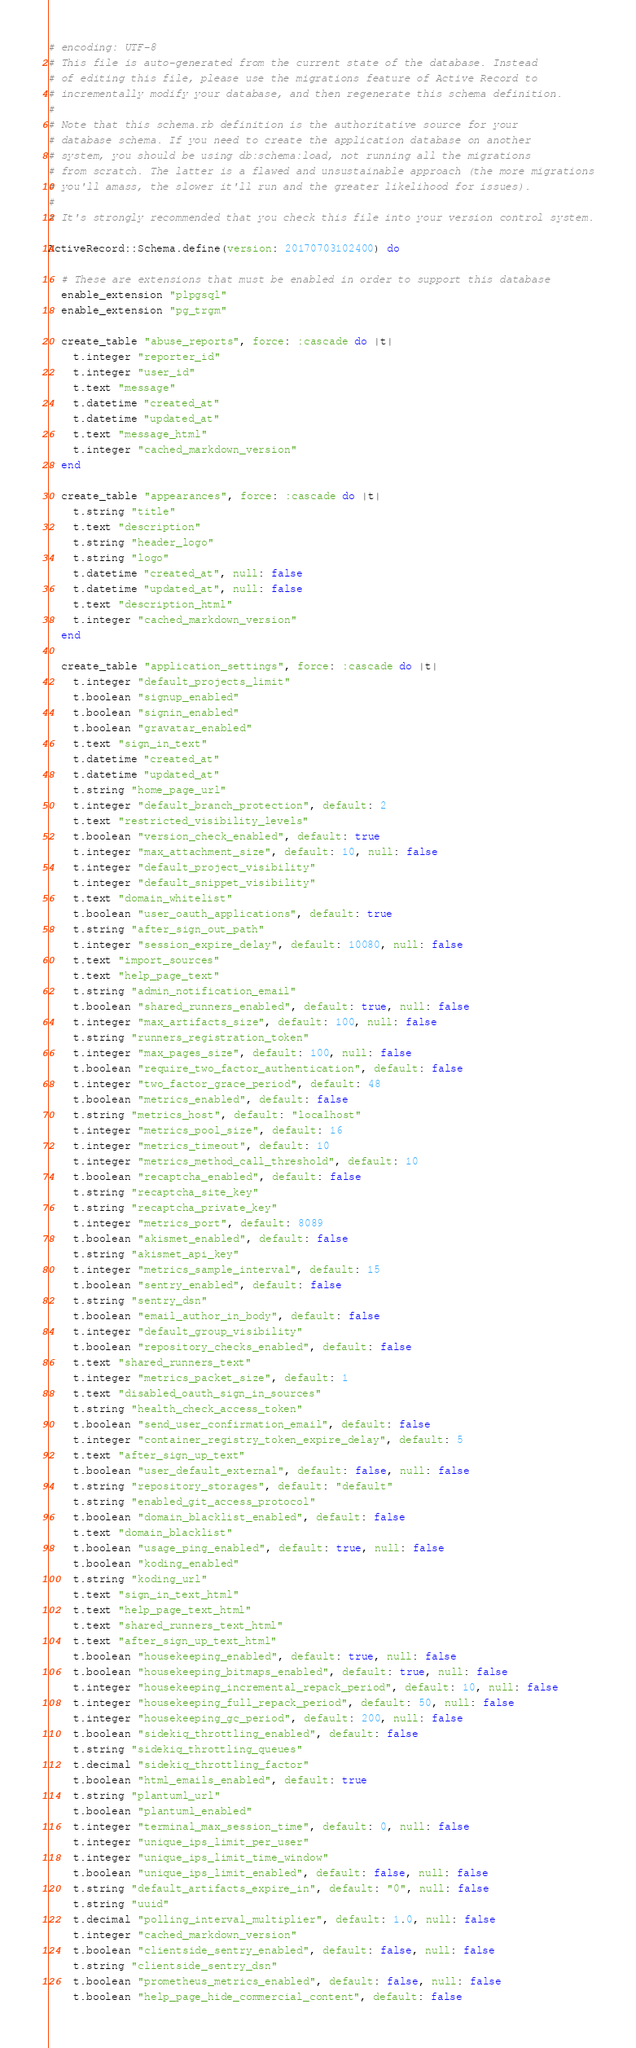<code> <loc_0><loc_0><loc_500><loc_500><_Ruby_># encoding: UTF-8
# This file is auto-generated from the current state of the database. Instead
# of editing this file, please use the migrations feature of Active Record to
# incrementally modify your database, and then regenerate this schema definition.
#
# Note that this schema.rb definition is the authoritative source for your
# database schema. If you need to create the application database on another
# system, you should be using db:schema:load, not running all the migrations
# from scratch. The latter is a flawed and unsustainable approach (the more migrations
# you'll amass, the slower it'll run and the greater likelihood for issues).
#
# It's strongly recommended that you check this file into your version control system.

ActiveRecord::Schema.define(version: 20170703102400) do

  # These are extensions that must be enabled in order to support this database
  enable_extension "plpgsql"
  enable_extension "pg_trgm"

  create_table "abuse_reports", force: :cascade do |t|
    t.integer "reporter_id"
    t.integer "user_id"
    t.text "message"
    t.datetime "created_at"
    t.datetime "updated_at"
    t.text "message_html"
    t.integer "cached_markdown_version"
  end

  create_table "appearances", force: :cascade do |t|
    t.string "title"
    t.text "description"
    t.string "header_logo"
    t.string "logo"
    t.datetime "created_at", null: false
    t.datetime "updated_at", null: false
    t.text "description_html"
    t.integer "cached_markdown_version"
  end

  create_table "application_settings", force: :cascade do |t|
    t.integer "default_projects_limit"
    t.boolean "signup_enabled"
    t.boolean "signin_enabled"
    t.boolean "gravatar_enabled"
    t.text "sign_in_text"
    t.datetime "created_at"
    t.datetime "updated_at"
    t.string "home_page_url"
    t.integer "default_branch_protection", default: 2
    t.text "restricted_visibility_levels"
    t.boolean "version_check_enabled", default: true
    t.integer "max_attachment_size", default: 10, null: false
    t.integer "default_project_visibility"
    t.integer "default_snippet_visibility"
    t.text "domain_whitelist"
    t.boolean "user_oauth_applications", default: true
    t.string "after_sign_out_path"
    t.integer "session_expire_delay", default: 10080, null: false
    t.text "import_sources"
    t.text "help_page_text"
    t.string "admin_notification_email"
    t.boolean "shared_runners_enabled", default: true, null: false
    t.integer "max_artifacts_size", default: 100, null: false
    t.string "runners_registration_token"
    t.integer "max_pages_size", default: 100, null: false
    t.boolean "require_two_factor_authentication", default: false
    t.integer "two_factor_grace_period", default: 48
    t.boolean "metrics_enabled", default: false
    t.string "metrics_host", default: "localhost"
    t.integer "metrics_pool_size", default: 16
    t.integer "metrics_timeout", default: 10
    t.integer "metrics_method_call_threshold", default: 10
    t.boolean "recaptcha_enabled", default: false
    t.string "recaptcha_site_key"
    t.string "recaptcha_private_key"
    t.integer "metrics_port", default: 8089
    t.boolean "akismet_enabled", default: false
    t.string "akismet_api_key"
    t.integer "metrics_sample_interval", default: 15
    t.boolean "sentry_enabled", default: false
    t.string "sentry_dsn"
    t.boolean "email_author_in_body", default: false
    t.integer "default_group_visibility"
    t.boolean "repository_checks_enabled", default: false
    t.text "shared_runners_text"
    t.integer "metrics_packet_size", default: 1
    t.text "disabled_oauth_sign_in_sources"
    t.string "health_check_access_token"
    t.boolean "send_user_confirmation_email", default: false
    t.integer "container_registry_token_expire_delay", default: 5
    t.text "after_sign_up_text"
    t.boolean "user_default_external", default: false, null: false
    t.string "repository_storages", default: "default"
    t.string "enabled_git_access_protocol"
    t.boolean "domain_blacklist_enabled", default: false
    t.text "domain_blacklist"
    t.boolean "usage_ping_enabled", default: true, null: false
    t.boolean "koding_enabled"
    t.string "koding_url"
    t.text "sign_in_text_html"
    t.text "help_page_text_html"
    t.text "shared_runners_text_html"
    t.text "after_sign_up_text_html"
    t.boolean "housekeeping_enabled", default: true, null: false
    t.boolean "housekeeping_bitmaps_enabled", default: true, null: false
    t.integer "housekeeping_incremental_repack_period", default: 10, null: false
    t.integer "housekeeping_full_repack_period", default: 50, null: false
    t.integer "housekeeping_gc_period", default: 200, null: false
    t.boolean "sidekiq_throttling_enabled", default: false
    t.string "sidekiq_throttling_queues"
    t.decimal "sidekiq_throttling_factor"
    t.boolean "html_emails_enabled", default: true
    t.string "plantuml_url"
    t.boolean "plantuml_enabled"
    t.integer "terminal_max_session_time", default: 0, null: false
    t.integer "unique_ips_limit_per_user"
    t.integer "unique_ips_limit_time_window"
    t.boolean "unique_ips_limit_enabled", default: false, null: false
    t.string "default_artifacts_expire_in", default: "0", null: false
    t.string "uuid"
    t.decimal "polling_interval_multiplier", default: 1.0, null: false
    t.integer "cached_markdown_version"
    t.boolean "clientside_sentry_enabled", default: false, null: false
    t.string "clientside_sentry_dsn"
    t.boolean "prometheus_metrics_enabled", default: false, null: false
    t.boolean "help_page_hide_commercial_content", default: false</code> 